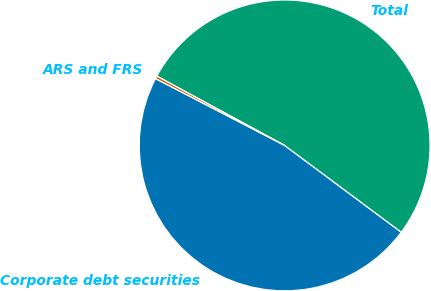<chart> <loc_0><loc_0><loc_500><loc_500><pie_chart><fcel>Corporate debt securities<fcel>Total<fcel>ARS and FRS<nl><fcel>47.42%<fcel>52.27%<fcel>0.31%<nl></chart> 